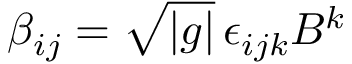Convert formula to latex. <formula><loc_0><loc_0><loc_500><loc_500>\beta _ { i j } = \sqrt { | g | } \, \epsilon _ { i j k } B ^ { k }</formula> 